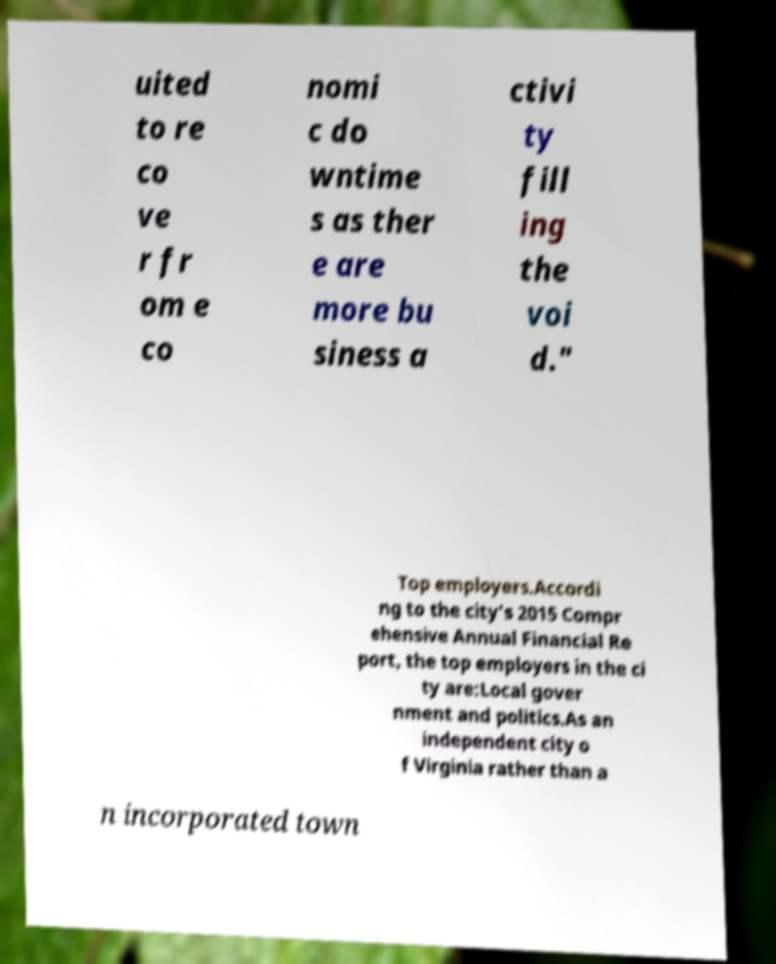There's text embedded in this image that I need extracted. Can you transcribe it verbatim? uited to re co ve r fr om e co nomi c do wntime s as ther e are more bu siness a ctivi ty fill ing the voi d." Top employers.Accordi ng to the city's 2015 Compr ehensive Annual Financial Re port, the top employers in the ci ty are:Local gover nment and politics.As an independent city o f Virginia rather than a n incorporated town 